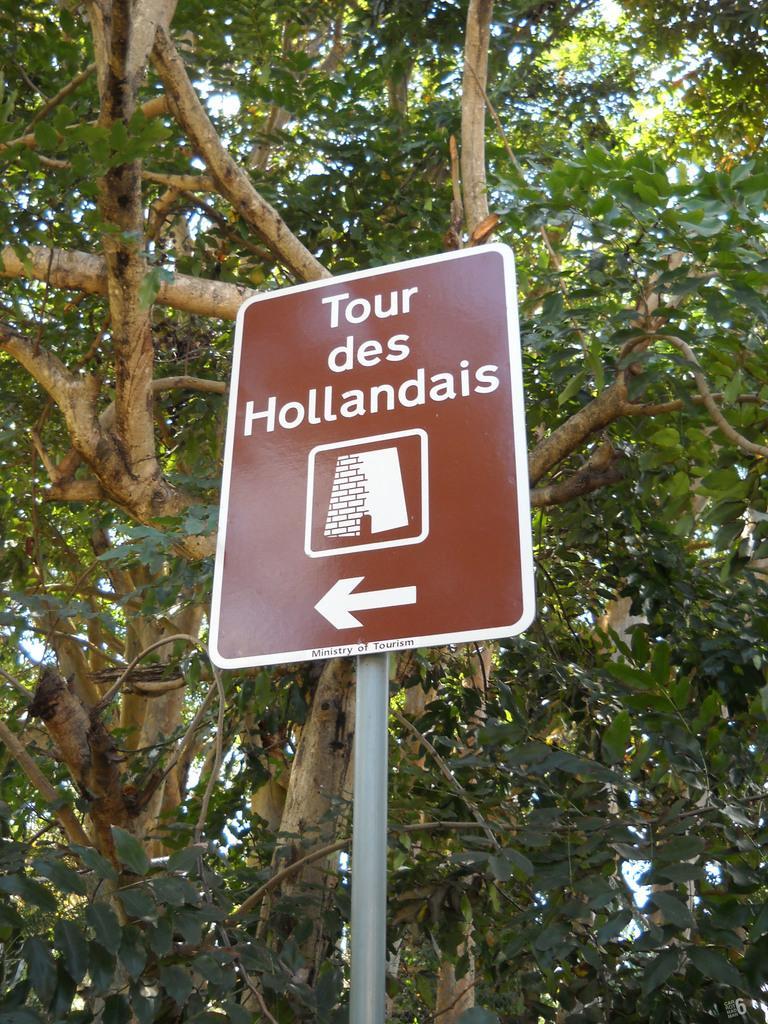In one or two sentences, can you explain what this image depicts? In this image there is a sign board with some text, image and an arrow mark, behind that there is a tree. 